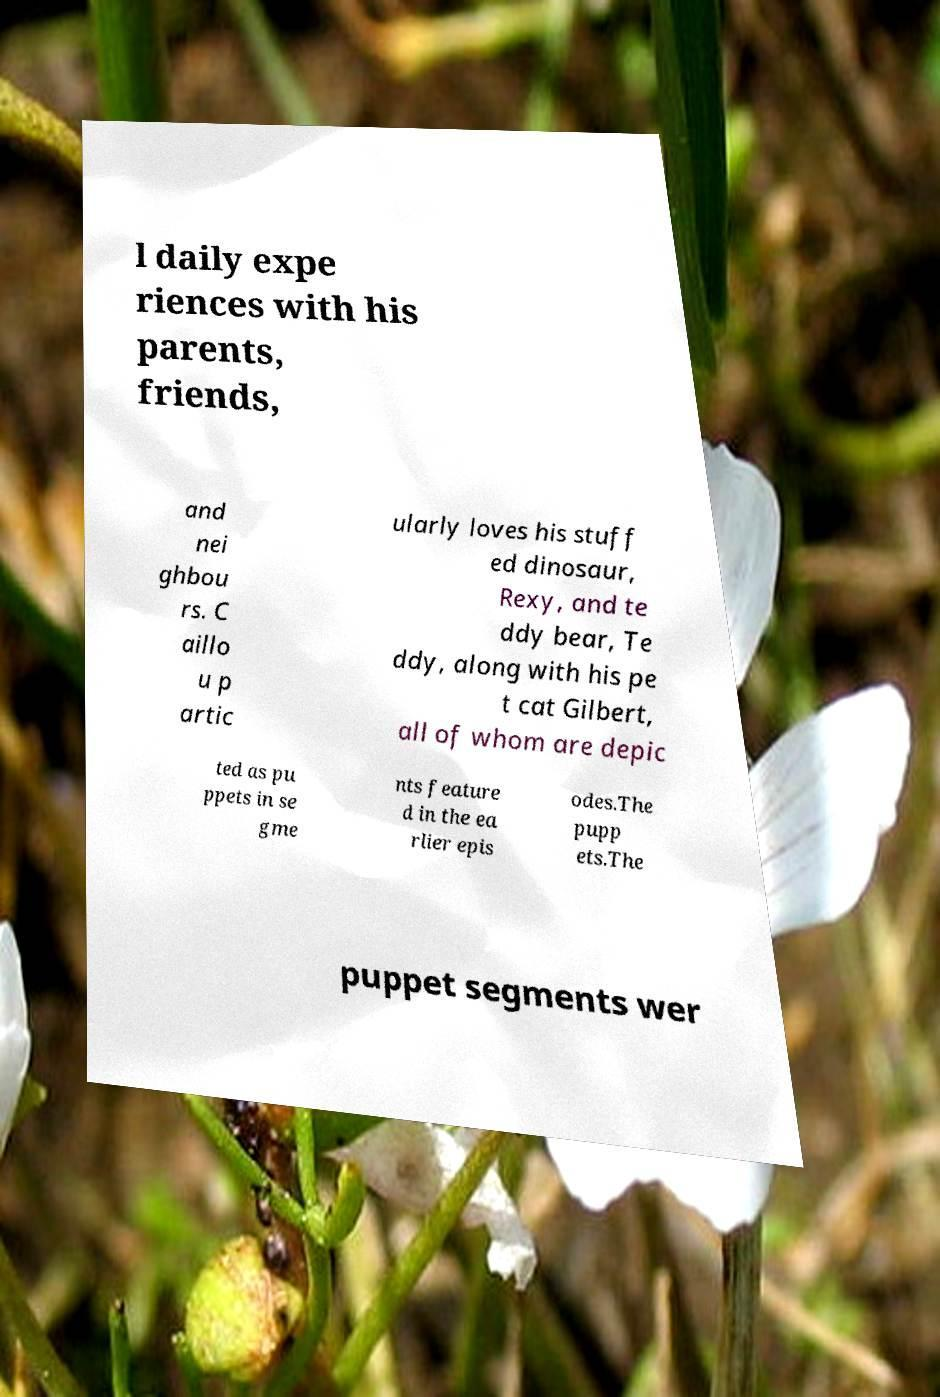Can you accurately transcribe the text from the provided image for me? l daily expe riences with his parents, friends, and nei ghbou rs. C aillo u p artic ularly loves his stuff ed dinosaur, Rexy, and te ddy bear, Te ddy, along with his pe t cat Gilbert, all of whom are depic ted as pu ppets in se gme nts feature d in the ea rlier epis odes.The pupp ets.The puppet segments wer 